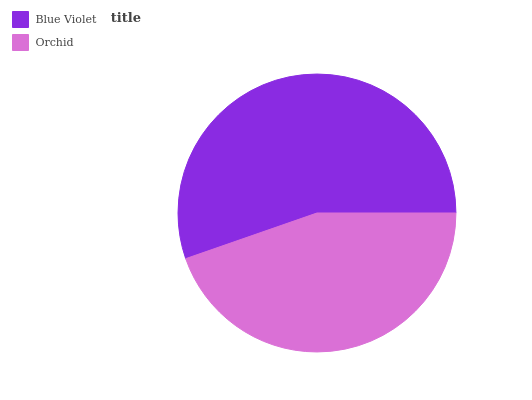Is Orchid the minimum?
Answer yes or no. Yes. Is Blue Violet the maximum?
Answer yes or no. Yes. Is Orchid the maximum?
Answer yes or no. No. Is Blue Violet greater than Orchid?
Answer yes or no. Yes. Is Orchid less than Blue Violet?
Answer yes or no. Yes. Is Orchid greater than Blue Violet?
Answer yes or no. No. Is Blue Violet less than Orchid?
Answer yes or no. No. Is Blue Violet the high median?
Answer yes or no. Yes. Is Orchid the low median?
Answer yes or no. Yes. Is Orchid the high median?
Answer yes or no. No. Is Blue Violet the low median?
Answer yes or no. No. 